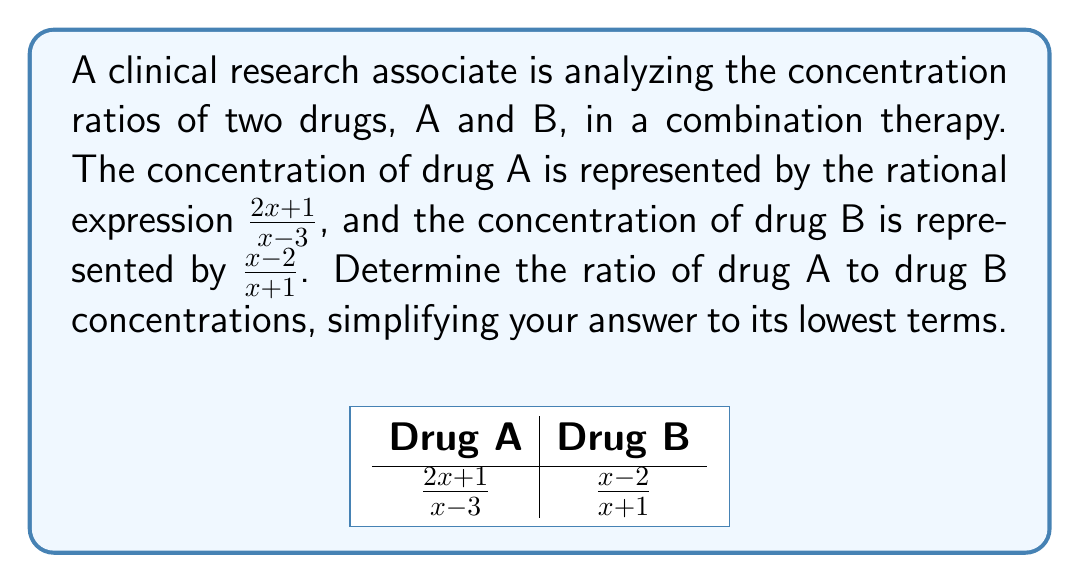Provide a solution to this math problem. To find the ratio of drug A to drug B concentrations, we need to divide the rational expression for drug A by the rational expression for drug B. We'll follow these steps:

1) Set up the division of the two rational expressions:

   $$\frac{\frac{2x+1}{x-3}}{\frac{x-2}{x+1}}$$

2) To divide rational expressions, we multiply the first fraction by the reciprocal of the second:

   $$\frac{2x+1}{x-3} \cdot \frac{x+1}{x-2}$$

3) Multiply the numerators and denominators:

   $$\frac{(2x+1)(x+1)}{(x-3)(x-2)}$$

4) Expand the numerator and denominator:

   $$\frac{2x^2+2x+x+1}{x^2-5x+6}$$

5) Simplify the numerator:

   $$\frac{2x^2+3x+1}{x^2-5x+6}$$

6) Factor the numerator and denominator if possible:
   The numerator doesn't factor further.
   The denominator factors to $(x-2)(x-3)$

   $$\frac{2x^2+3x+1}{(x-2)(x-3)}$$

7) This is the simplified ratio in its lowest terms, as there are no common factors between the numerator and denominator.
Answer: $\frac{2x^2+3x+1}{(x-2)(x-3)}$ 